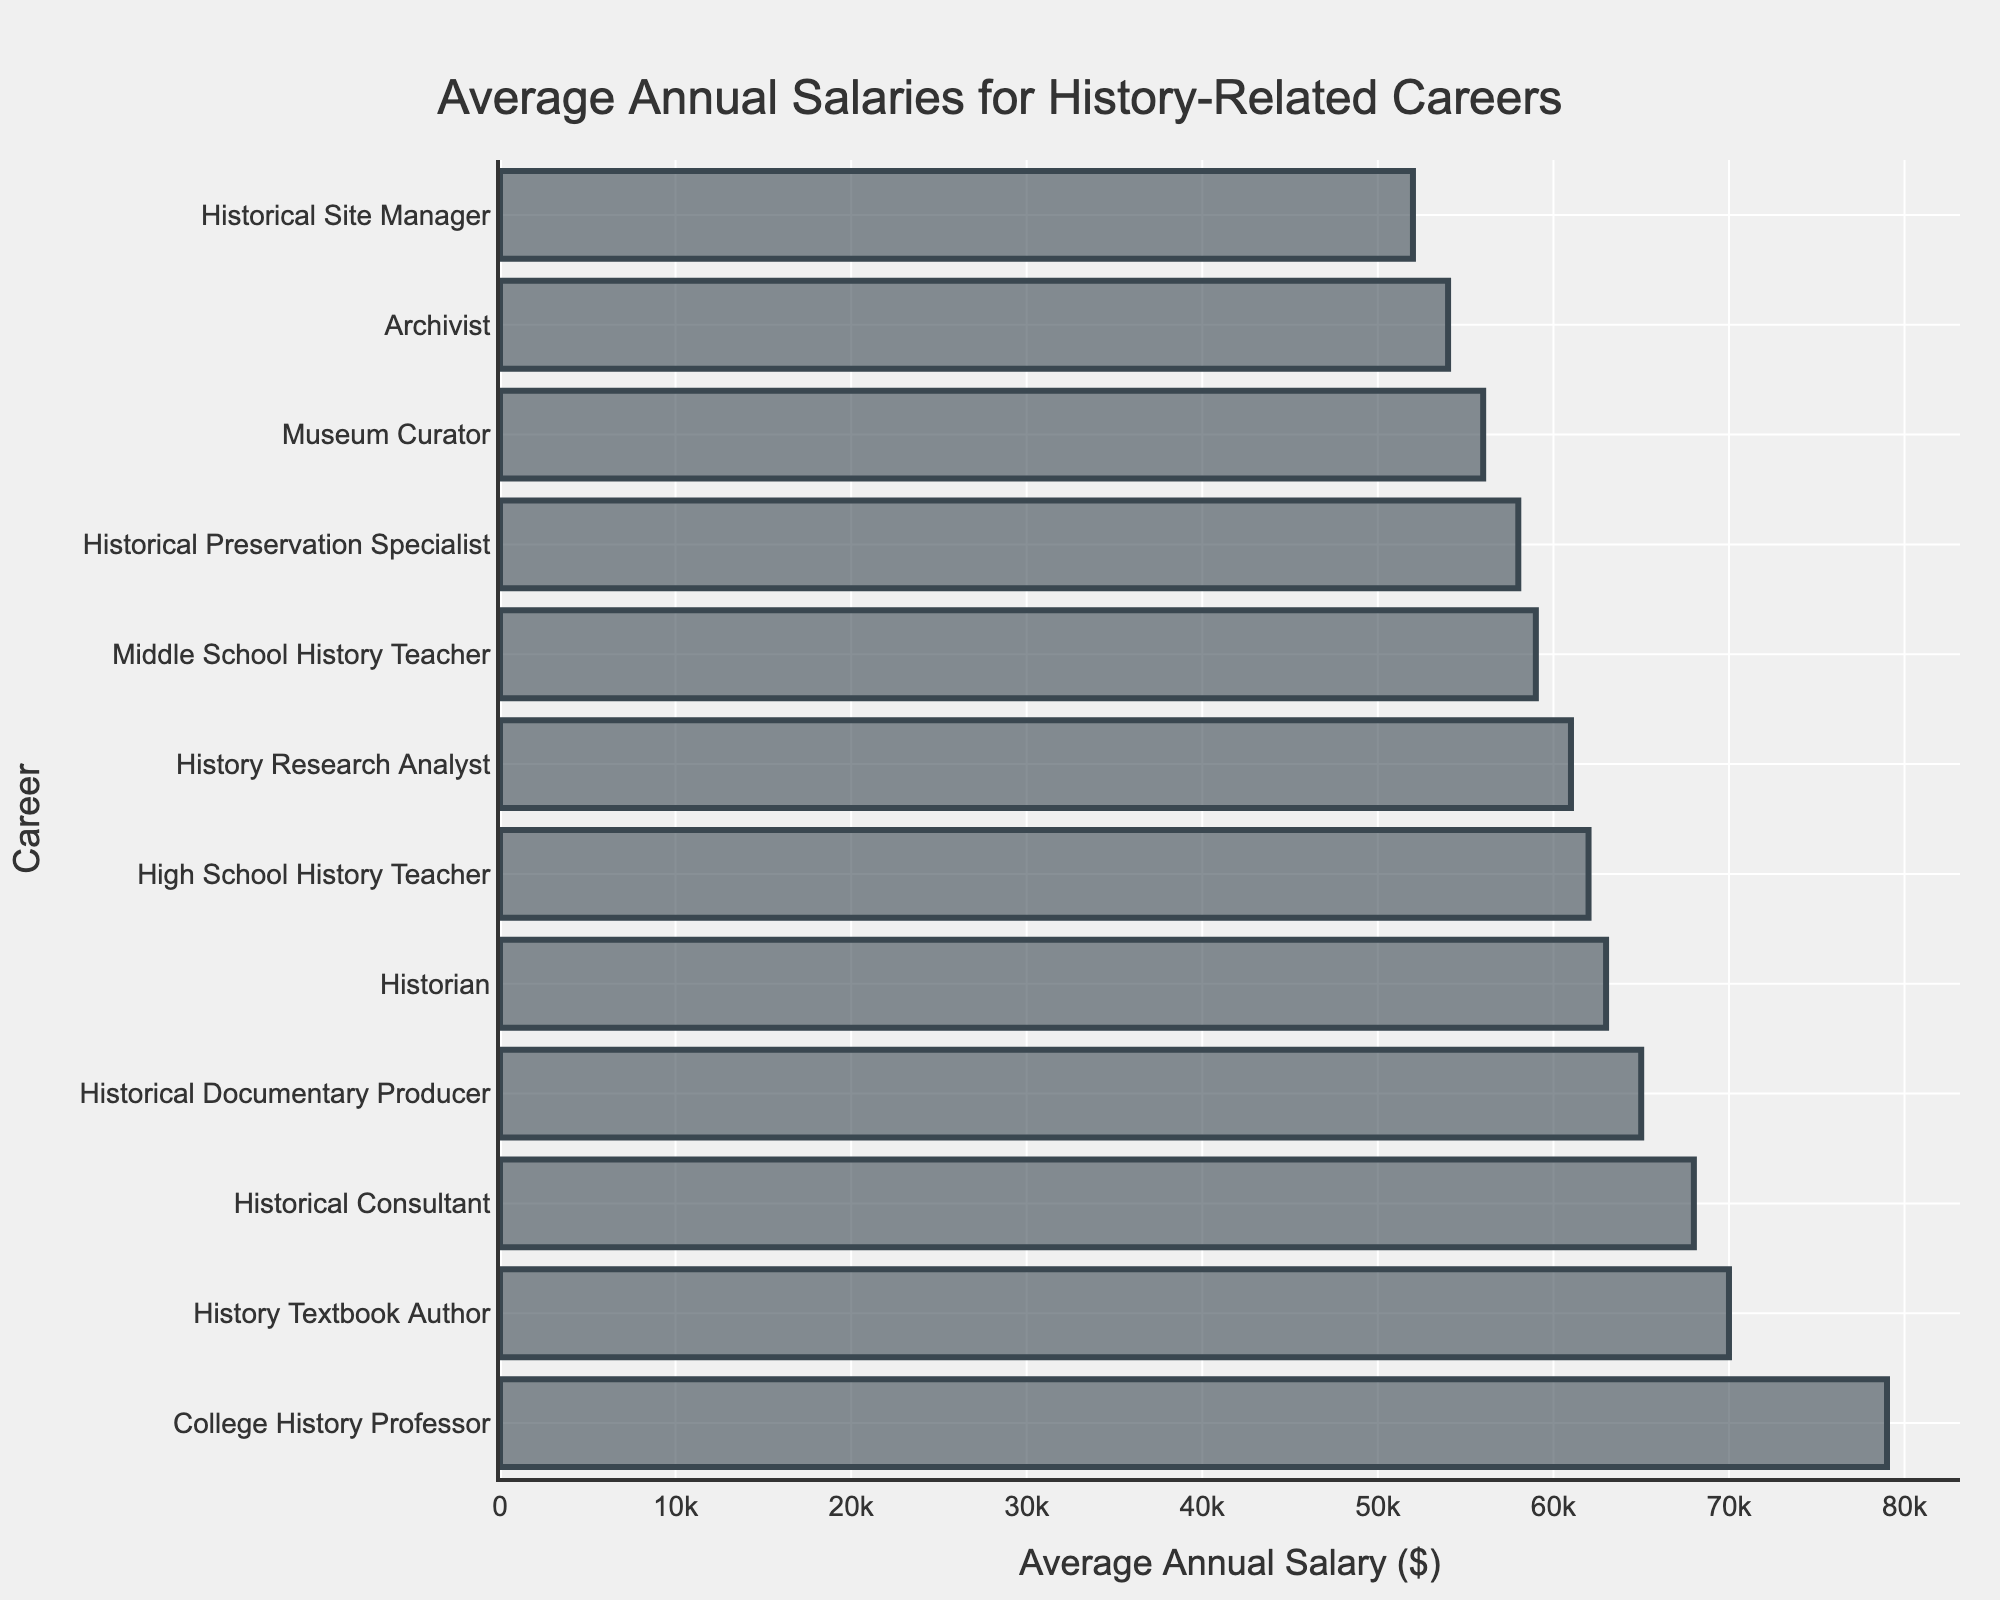what is the highest-paid history-related career? The highest bar corresponds to the "College History Professor" with an average annual salary of $79,000.
Answer: College History Professor Which history-related career has the lowest average annual salary? The shortest bar corresponds to the "Historical Site Manager" with an average annual salary of $52,000.
Answer: Historical Site Manager What is the difference in average annual salary between a College History Professor and a Museum Curator? The average salary of a College History Professor is $79,000 and a Museum Curator is $56,000. The difference is $79,000 - $56,000 = $23,000.
Answer: $23,000 Which career has a higher average annual salary: Archivist or Historian? By how much? The average salary of an Archivist is $54,000, and a Historian is $63,000. A Historian earns $63,000 - $54,000 = $9,000 more.
Answer: Historian, $9,000 more What is the average annual salary for careers in teaching (High School, Middle School, College)? The average salaries are $62,000 (High School), $59,000 (Middle School), and $79,000 (College). The average is ($62,000 + $59,000 + $79,000) / 3 = $66,666.67.
Answer: $66,666.67 What are the careers with average annual salaries above $65,000? The careers with average annual salaries above $65,000 are College History Professor ($79,000), History Textbook Author ($70,000), Historical Consultant ($68,000), Historical Documentary Producer ($65,000), and Historian ($63,000) which is just below the threshold.
Answer: College History Professor, History Textbook Author, Historical Consultant, Historical Documentary Producer Sum the average annual salaries of a Historical Consultant, Historical Documentary Producer, and a History Textbook Author. The salaries are $68,000 (Historical Consultant), $65,000 (Historical Documentary Producer), and $70,000 (History Textbook Author). The sum is $68,000 + $65,000 + $70,000 = $203,000.
Answer: $203,000 What is the median annual salary for all the listed history-related careers? Arrange the salaries in ascending order: $52,000, $54,000, $56,000, $58,000, $59,000, $61,000, $62,000, $63,000, $65,000, $68,000, $70,000, $79,000. The median is the average of the 6th and 7th values: ($61,000 + $62,000) / 2 = $61,500.
Answer: $61,500 Which history-related career has almost the same average annual salary as a High School History Teacher? The average salary of a High School History Teacher is $62,000. The closest salary to this is the History Research Analyst with $61,000.
Answer: History Research Analyst Which career’s average salary falls closest to the average annual salary of all listed history-related careers? The total of all salaries, adding the respective values, is $660,000. The average is $660,000 / 12 = $55,000. The Archivist ($54,000) has the closest salary to this value.
Answer: Archivist 